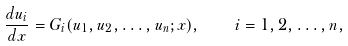<formula> <loc_0><loc_0><loc_500><loc_500>\frac { d u _ { i } } { d x } = G _ { i } ( u _ { 1 } , u _ { 2 } , \dots , u _ { n } ; x ) , \quad i = 1 , 2 , \dots , n ,</formula> 